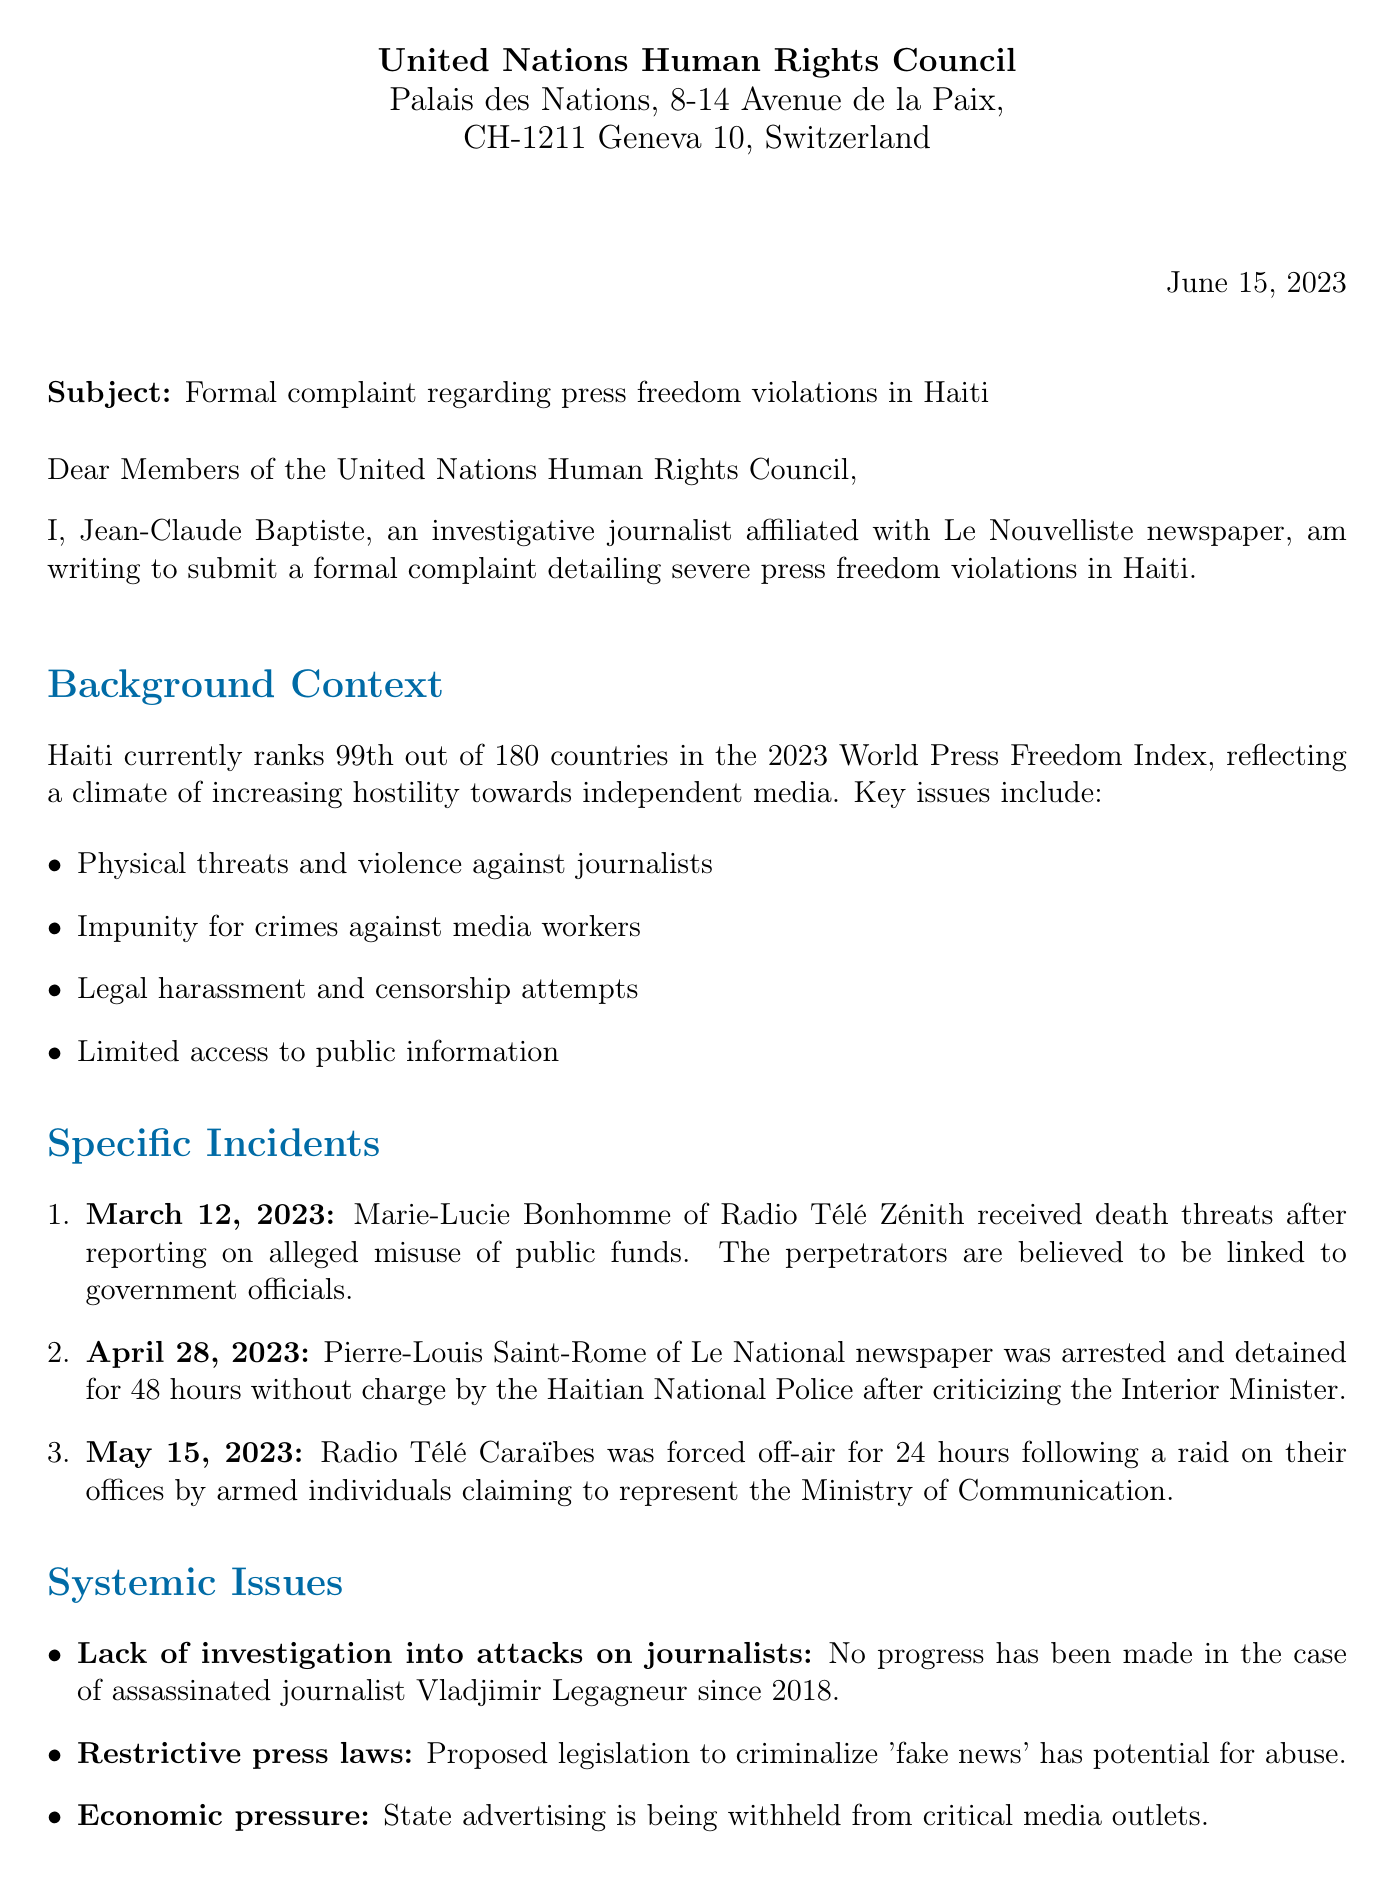What is the recipient of the letter? The recipient of the letter is the United Nations Human Rights Council, as stated at the beginning of the document.
Answer: United Nations Human Rights Council When was the letter written? The date of the letter is prominently mentioned in the header, indicating when it was submitted.
Answer: June 15, 2023 Who is the complainant? The complainant's name and occupation are detailed in the introduction of the letter.
Answer: Jean-Claude Baptiste What event occurred on March 12, 2023? The specific incident mentioned on this date includes the victim, outlet, and a brief description of the event.
Answer: Death threats to Marie-Lucie Bonhomme How many incidents are specifically listed in the letter? The document includes a numbered list of specific incidents related to press freedom violations in Haiti.
Answer: Three What does the letter request regarding journalist safety? The requested actions section details measures aimed at ensuring journalists' safety in Haiti.
Answer: Urge the Haitian government to ensure the safety of journalists What rank does Haiti hold in the 2023 World Press Freedom Index? This information is provided in the background context section of the letter.
Answer: 99th What is one example of a systemic issue discussed? The systemic issues section outlines various problems affecting press freedom in Haiti, with specific examples given.
Answer: Lack of investigation into attacks on journalists Who signed the letter? The signature section provides the name, title, and contact information of the individual who authored the complaint.
Answer: Jean-Claude Baptiste 